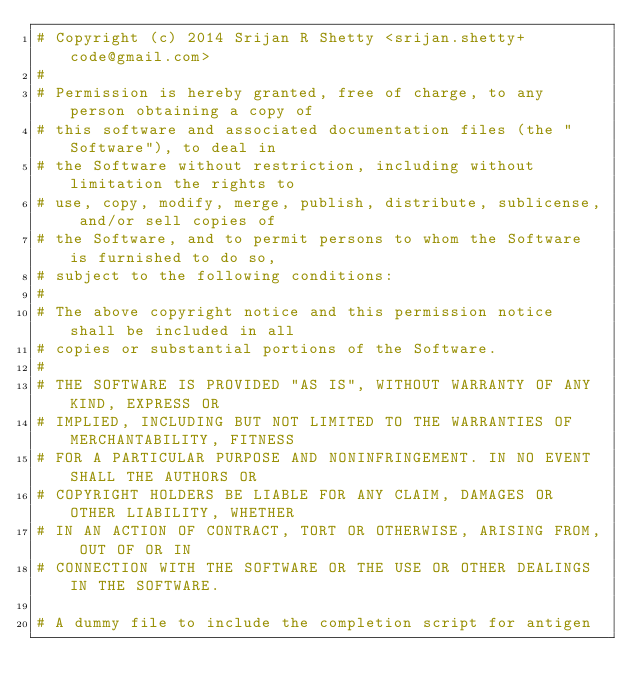Convert code to text. <code><loc_0><loc_0><loc_500><loc_500><_Bash_># Copyright (c) 2014 Srijan R Shetty <srijan.shetty+code@gmail.com>
#
# Permission is hereby granted, free of charge, to any person obtaining a copy of
# this software and associated documentation files (the "Software"), to deal in
# the Software without restriction, including without limitation the rights to
# use, copy, modify, merge, publish, distribute, sublicense, and/or sell copies of
# the Software, and to permit persons to whom the Software is furnished to do so,
# subject to the following conditions:
#
# The above copyright notice and this permission notice shall be included in all
# copies or substantial portions of the Software.
#
# THE SOFTWARE IS PROVIDED "AS IS", WITHOUT WARRANTY OF ANY KIND, EXPRESS OR
# IMPLIED, INCLUDING BUT NOT LIMITED TO THE WARRANTIES OF MERCHANTABILITY, FITNESS
# FOR A PARTICULAR PURPOSE AND NONINFRINGEMENT. IN NO EVENT SHALL THE AUTHORS OR
# COPYRIGHT HOLDERS BE LIABLE FOR ANY CLAIM, DAMAGES OR OTHER LIABILITY, WHETHER
# IN AN ACTION OF CONTRACT, TORT OR OTHERWISE, ARISING FROM, OUT OF OR IN
# CONNECTION WITH THE SOFTWARE OR THE USE OR OTHER DEALINGS IN THE SOFTWARE.

# A dummy file to include the completion script for antigen</code> 